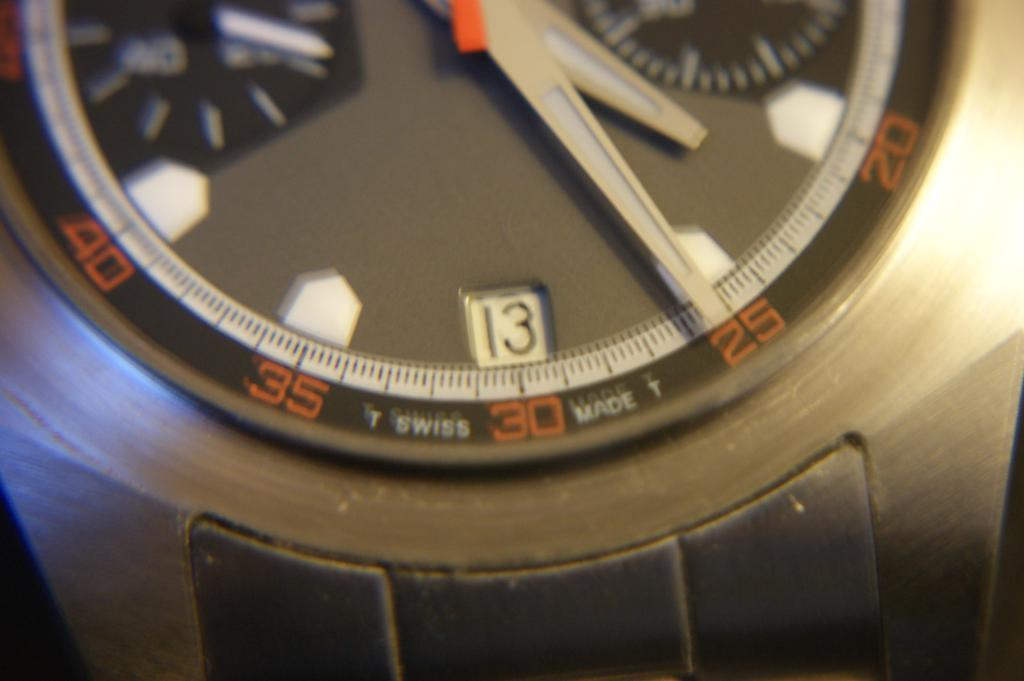<image>
Render a clear and concise summary of the photo. A clock says "T SWISS MADE T" at the bottom of the face. 